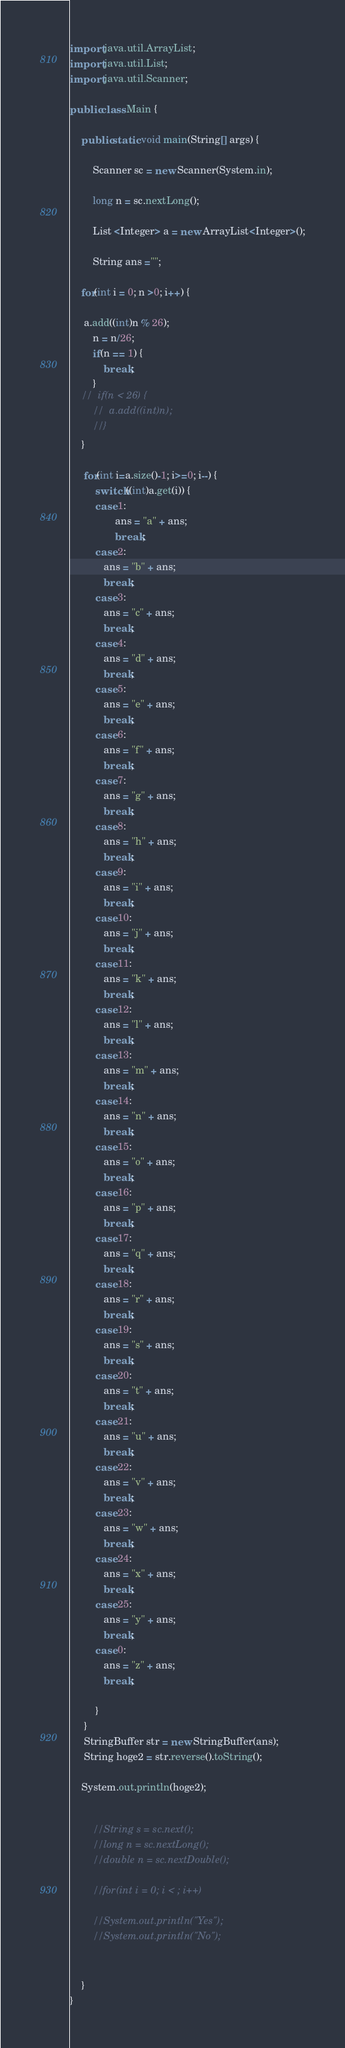<code> <loc_0><loc_0><loc_500><loc_500><_Java_>import java.util.ArrayList;
import java.util.List;
import java.util.Scanner;

public class Main {

	public static void main(String[] args) {

		Scanner sc = new Scanner(System.in);
		
		long n = sc.nextLong();
		
		List <Integer> a = new ArrayList<Integer>();
		
		String ans ="";
		
	for(int i = 0; n >0; i++) {
	
	 a.add((int)n % 26);
		n = n/26;
		if(n == 1) {
			break;
		}
	//	if(n < 26) {
		//	a.add((int)n);
		//}
	}
	
	 for(int i=a.size()-1; i>=0; i--) {
         switch((int)a.get(i)) {
         case 1:
        	    ans = "a" + ans;
        	    break;
         case 2:
     	    ans = "b" + ans;
     	    break;
         case 3:
     	    ans = "c" + ans;
     	    break;
         case 4:
     	    ans = "d" + ans;
     	    break;
         case 5:
     	    ans = "e" + ans;
     	    break;
         case 6:
     	    ans = "f" + ans;
     	    break;
         case 7:
     	    ans = "g" + ans;
     	    break;
         case 8:
     	    ans = "h" + ans;
     	    break;
         case 9:
     	    ans = "i" + ans;
     	    break;
         case 10:
     	    ans = "j" + ans;
     	    break;
         case 11:
     	    ans = "k" + ans;
     	    break;
         case 12:
     	    ans = "l" + ans;
     	    break;
         case 13:
     	    ans = "m" + ans;
     	    break;
         case 14:
     	    ans = "n" + ans;
     	    break;
         case 15:
     	    ans = "o" + ans;
     	    break;
         case 16:
     	    ans = "p" + ans;
     	    break;
         case 17:
     	    ans = "q" + ans;
     	    break;
         case 18:
     	    ans = "r" + ans;
     	    break;
         case 19:
     	    ans = "s" + ans;
     	    break;
         case 20:
     	    ans = "t" + ans;
     	    break;
         case 21:
     	    ans = "u" + ans;
     	    break;
         case 22:
     	    ans = "v" + ans;
     	    break;
         case 23:
     	    ans = "w" + ans;
     	    break;
         case 24:
     	    ans = "x" + ans;
     	    break;
         case 25:
     	    ans = "y" + ans;
     	    break;
         case 0:
     	    ans = "z" + ans;
     	    break;
     	    
         }
     }
	 StringBuffer str = new StringBuffer(ans);
     String hoge2 = str.reverse().toString();
	 
	System.out.println(hoge2);
		
		
		//String s = sc.next();
		//long n = sc.nextLong();
		//double n = sc.nextDouble();
		
		//for(int i = 0; i < ; i++)

		//System.out.println("Yes");
		//System.out.println("No");
		

	}
}
</code> 